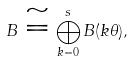<formula> <loc_0><loc_0><loc_500><loc_500>B \cong \bigoplus _ { k = 0 } ^ { s } B ( k \theta ) ,</formula> 